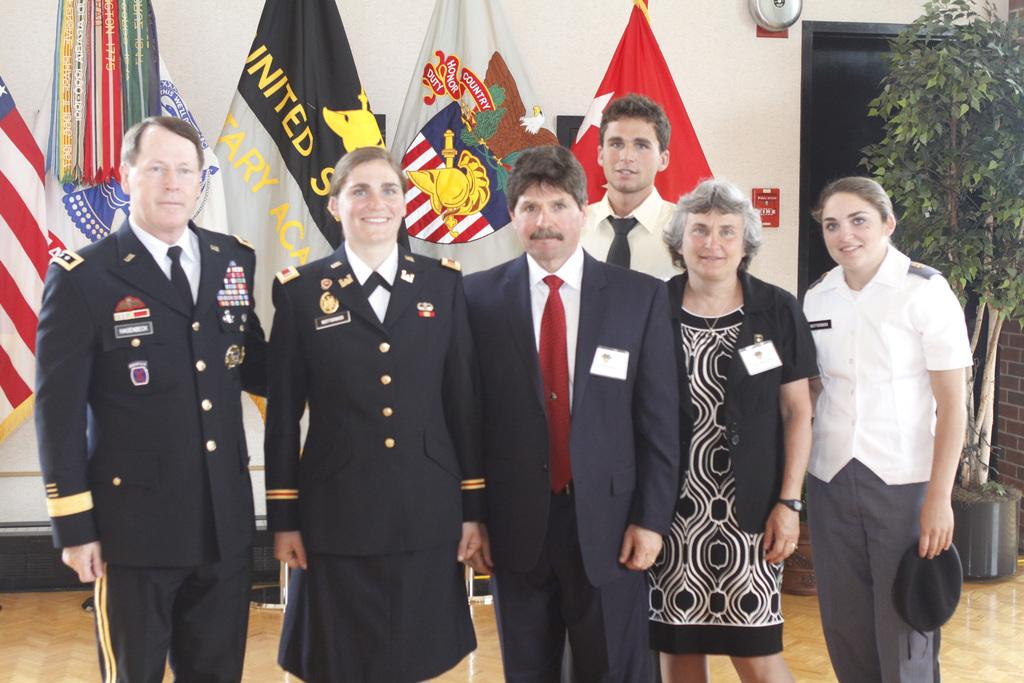What can be seen in the image? There are people standing in the image. What is located in the background of the image? There are flags and a wall visible in the background of the image. What type of plant is present in the image? There is a houseplant on the right side of the image. What feature allows access to the area shown in the image? There is a door visible in the image. What type of bun is being served at the meeting in the image? There is no meeting or bun present in the image. How does the bridge connect the two sides of the image? There is no bridge present in the image. 